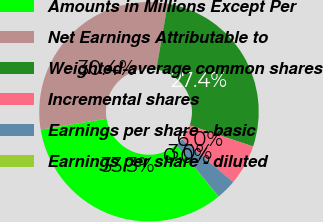Convert chart to OTSL. <chart><loc_0><loc_0><loc_500><loc_500><pie_chart><fcel>Amounts in Millions Except Per<fcel>Net Earnings Attributable to<fcel>Weighted-average common shares<fcel>Incremental shares<fcel>Earnings per share - basic<fcel>Earnings per share - diluted<nl><fcel>33.32%<fcel>30.35%<fcel>27.38%<fcel>5.95%<fcel>2.98%<fcel>0.02%<nl></chart> 